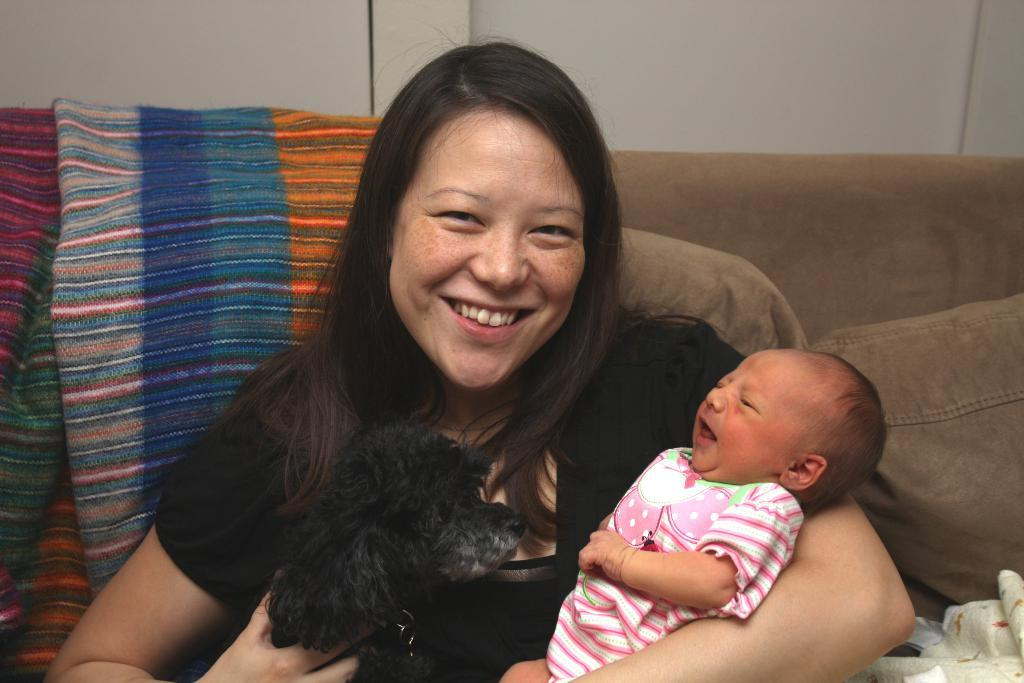Who is the main subject in the image? There is a woman in the image. What is the woman doing in the image? The woman is sitting and holding a baby in her hands. What can be seen in the background of the image? There is a sofa and a wall in the background of the image. What type of voice can be heard coming from the woman in the image? There is no indication of any sound or voice in the image, so it cannot be determined. 